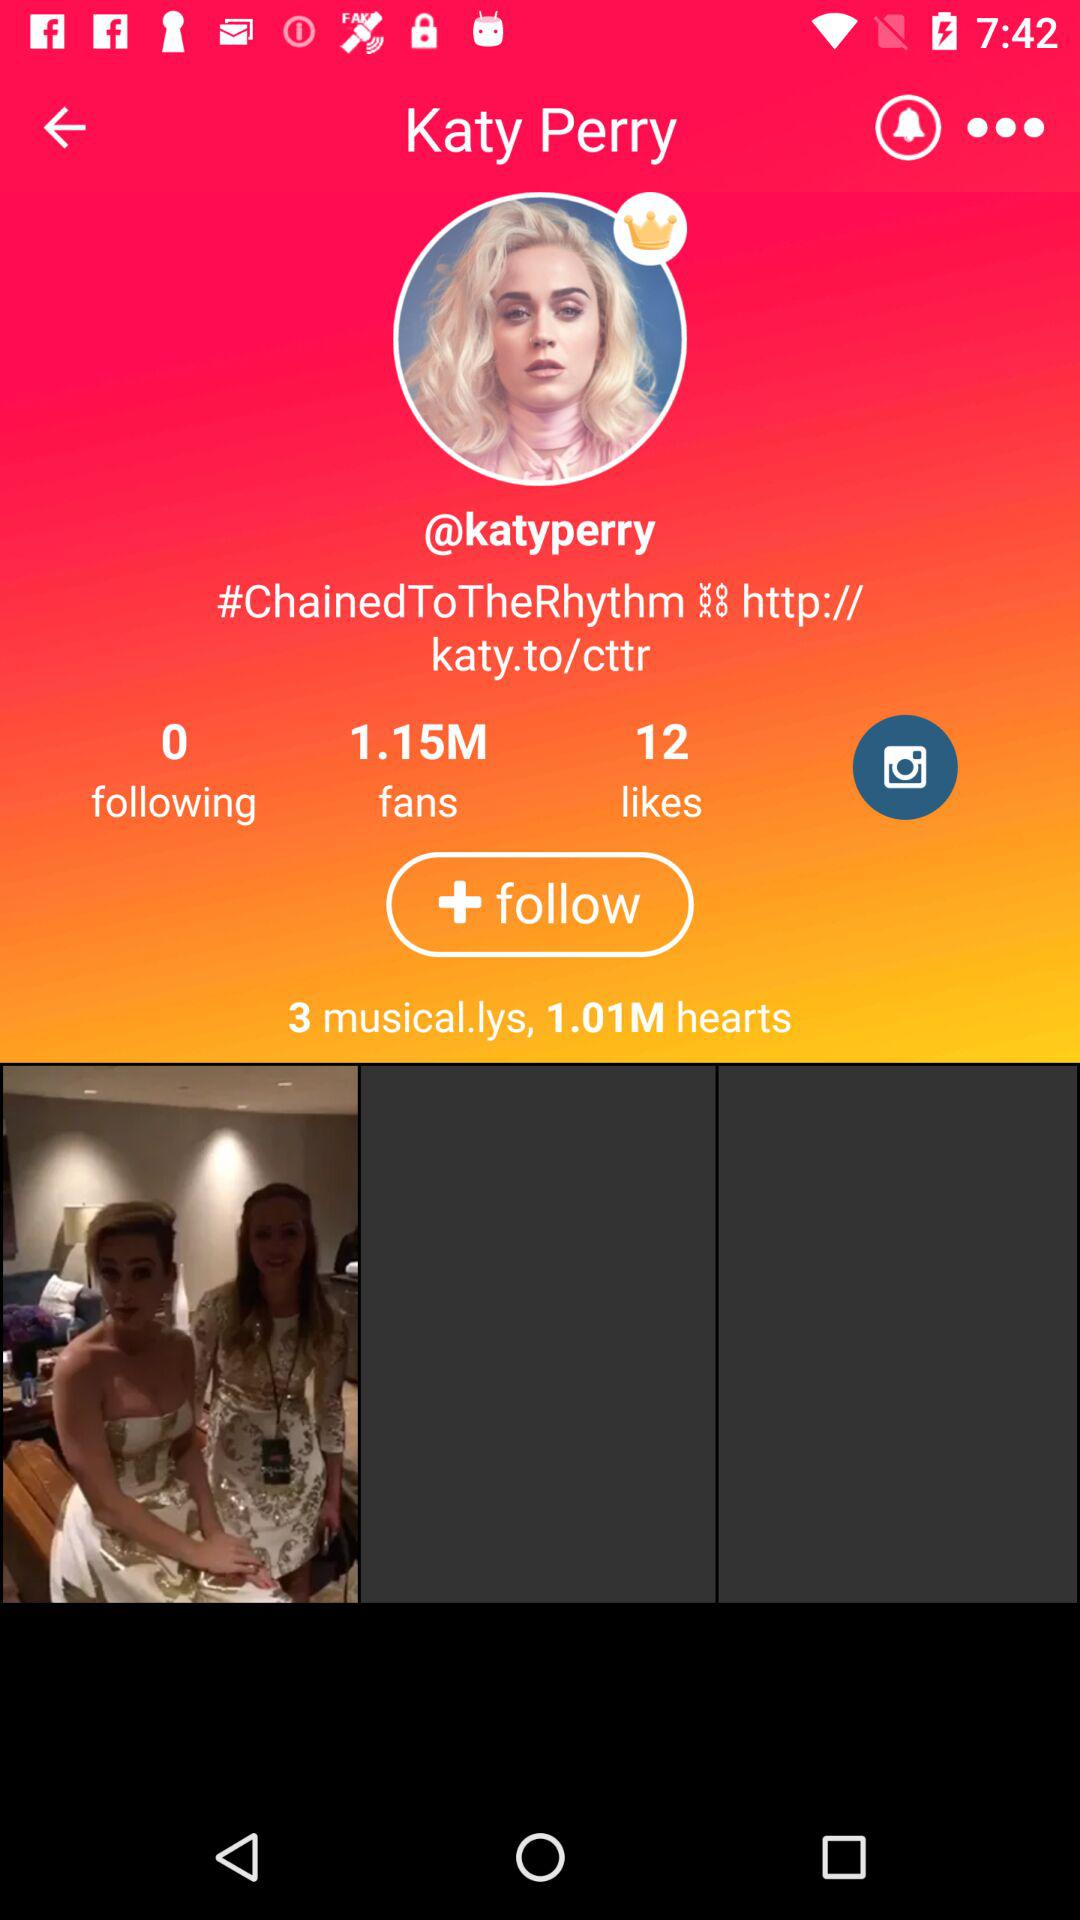What is the count of likes? The count of likes is 12. 